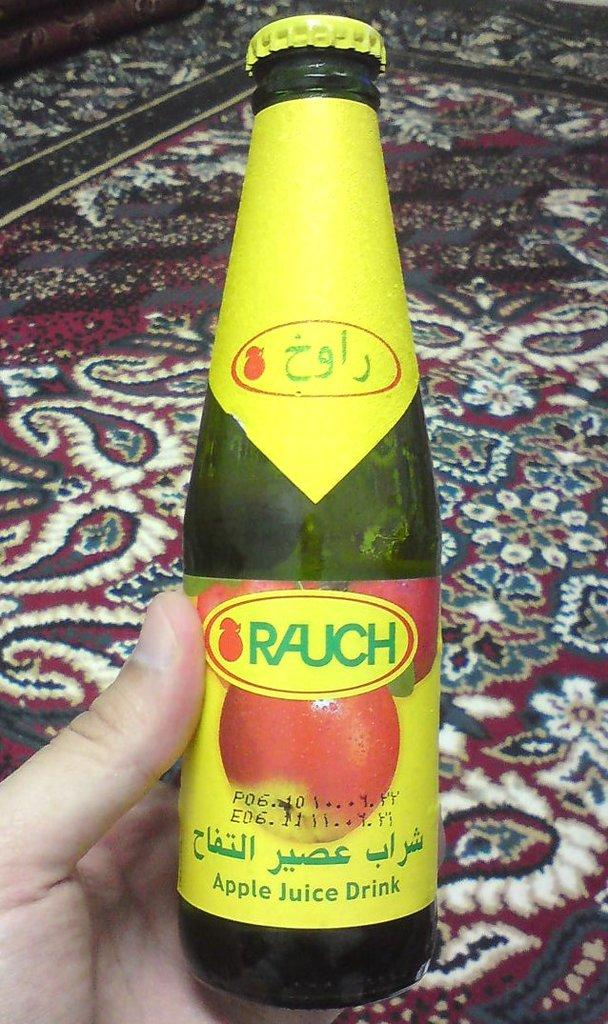<image>
Describe the image concisely. Someone holding a bottle of Rauch Apple juice drink. 